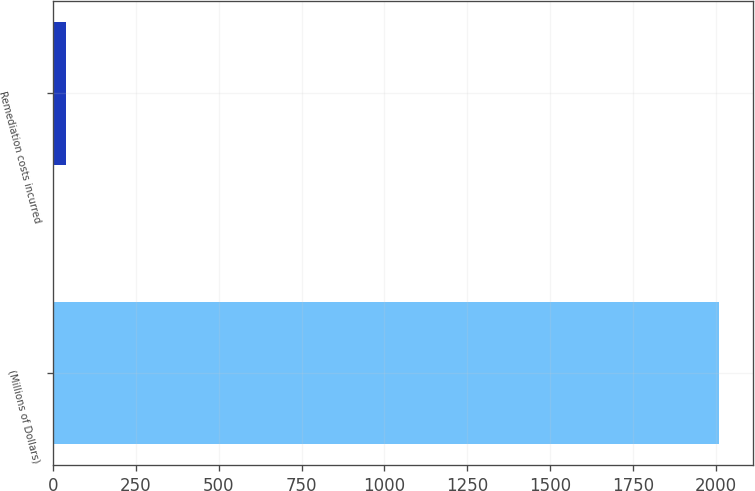Convert chart. <chart><loc_0><loc_0><loc_500><loc_500><bar_chart><fcel>(Millions of Dollars)<fcel>Remediation costs incurred<nl><fcel>2011<fcel>39<nl></chart> 